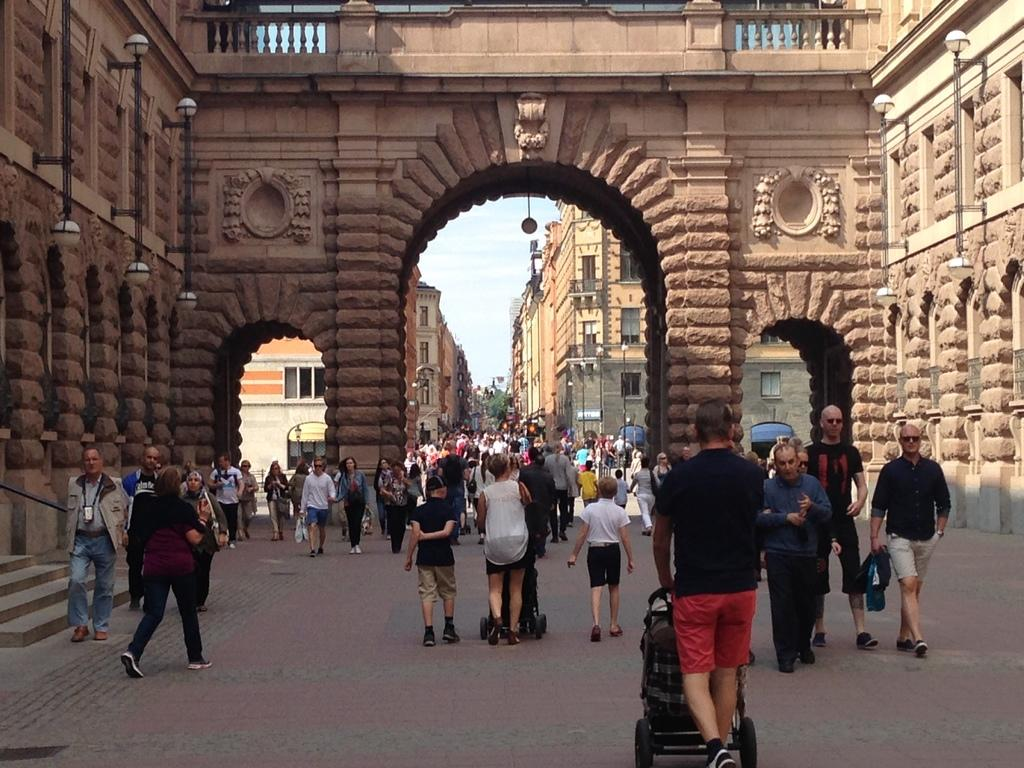How many people are in the image? There is a group of people in the image. What are the people doing in the image? The people are walking with baby prams. What can be seen in the background of the image? There is a brown color brick roman arch in the background of the image. Where is the sofa located in the image? There is no sofa present in the image. What type of bridge can be seen in the image? There is no bridge present in the image. 